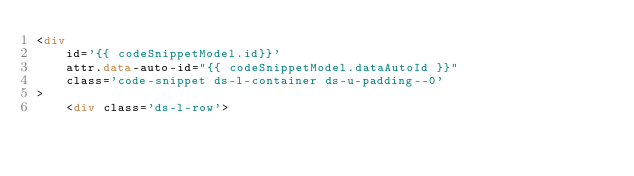<code> <loc_0><loc_0><loc_500><loc_500><_HTML_><div 
    id='{{ codeSnippetModel.id}}' 
    attr.data-auto-id="{{ codeSnippetModel.dataAutoId }}"
    class='code-snippet ds-l-container ds-u-padding--0' 
>
    <div class='ds-l-row'></code> 